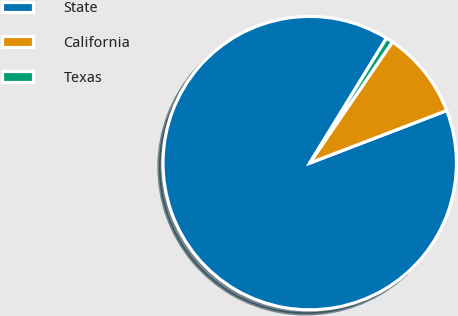<chart> <loc_0><loc_0><loc_500><loc_500><pie_chart><fcel>State<fcel>California<fcel>Texas<nl><fcel>89.6%<fcel>9.64%<fcel>0.76%<nl></chart> 